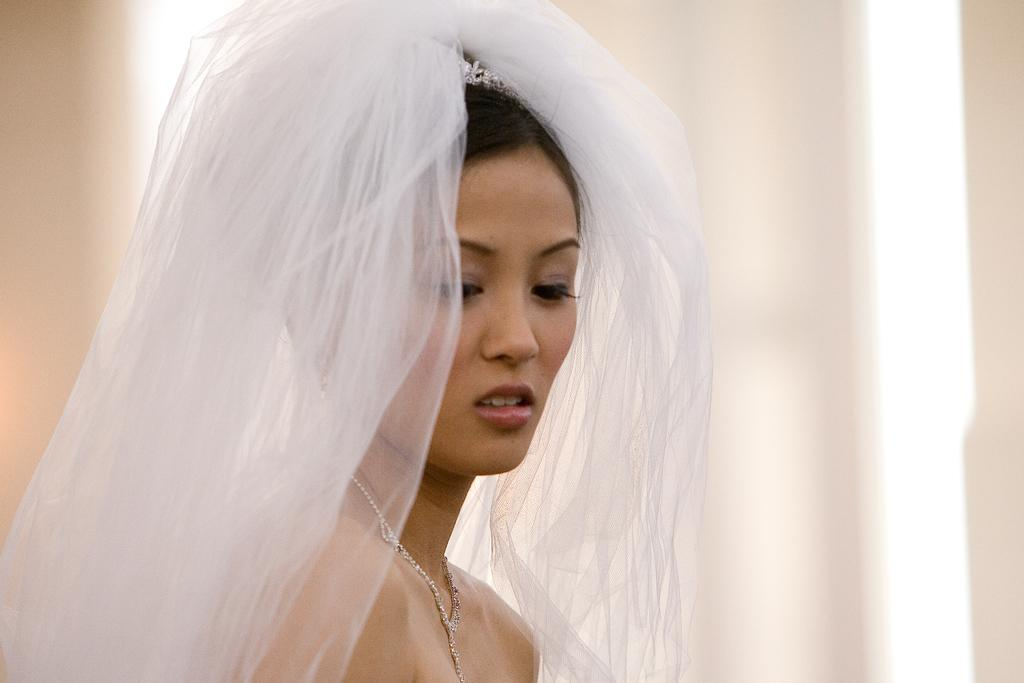Who is present in the image? There is a woman in the image. How many mint leaves are on the woman's badge in the image? There is no badge or mint leaves present in the image; it only features a woman. 